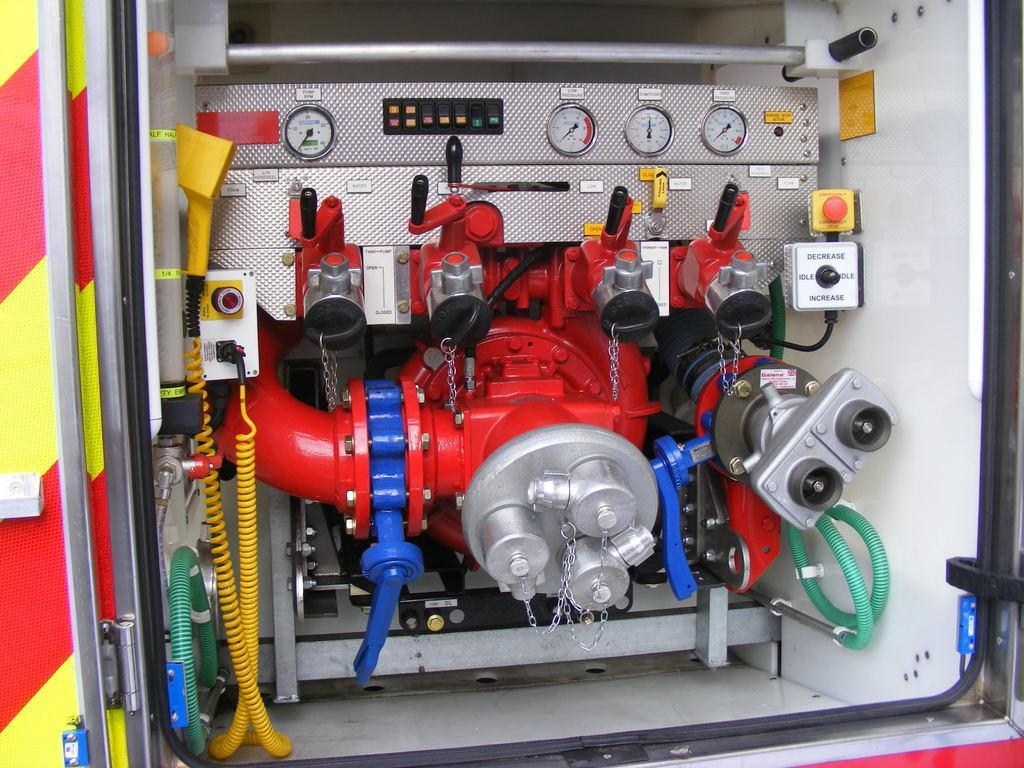Can you describe this image briefly? In this picture we can see red and silver machine engine in the front. On the top we can see the some pressure gauges. On the left side we can see the red and yellow van door. 